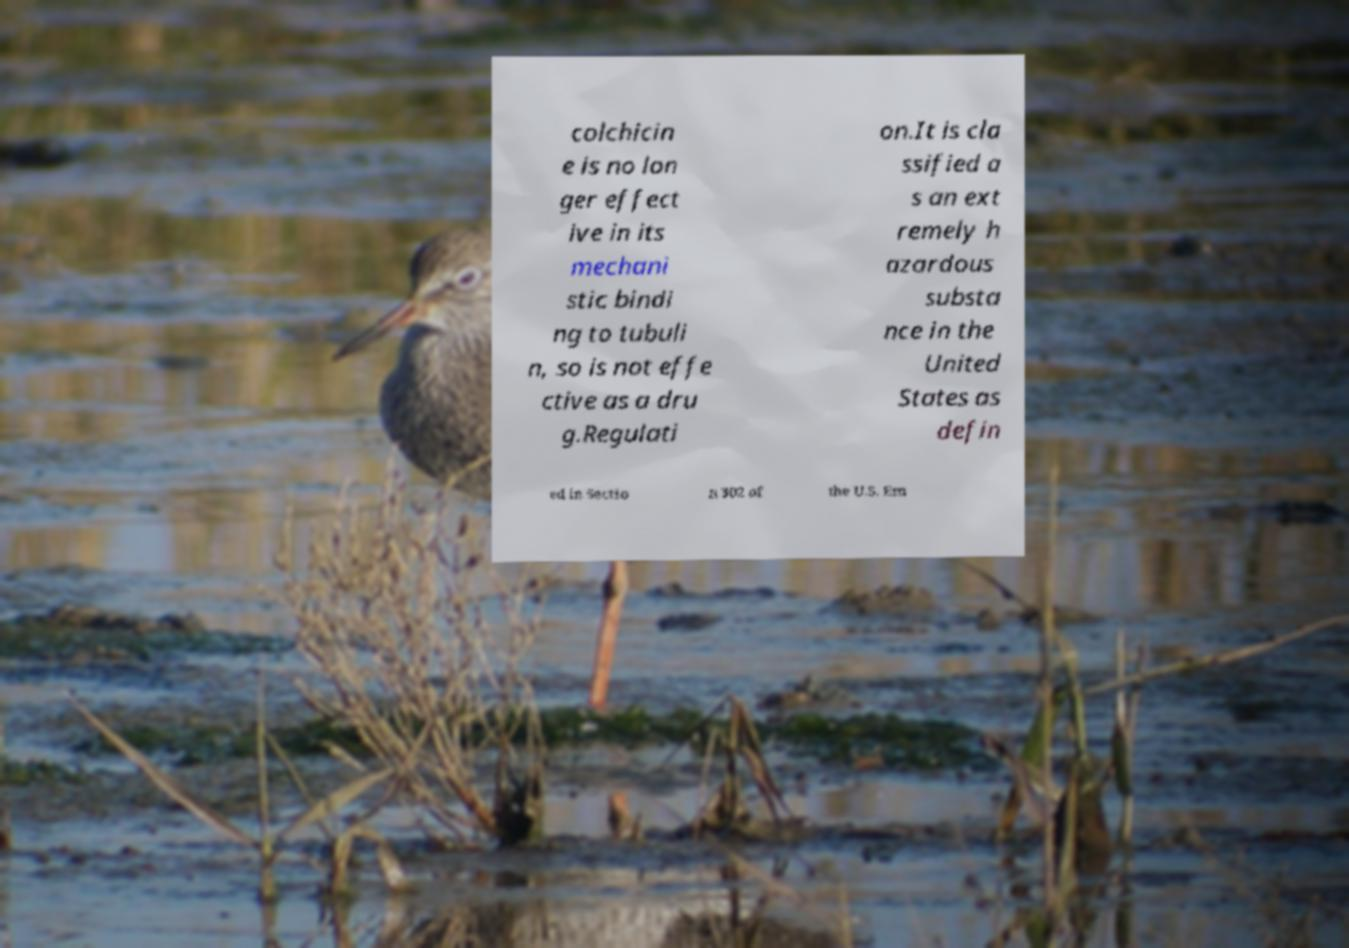What messages or text are displayed in this image? I need them in a readable, typed format. colchicin e is no lon ger effect ive in its mechani stic bindi ng to tubuli n, so is not effe ctive as a dru g.Regulati on.It is cla ssified a s an ext remely h azardous substa nce in the United States as defin ed in Sectio n 302 of the U.S. Em 